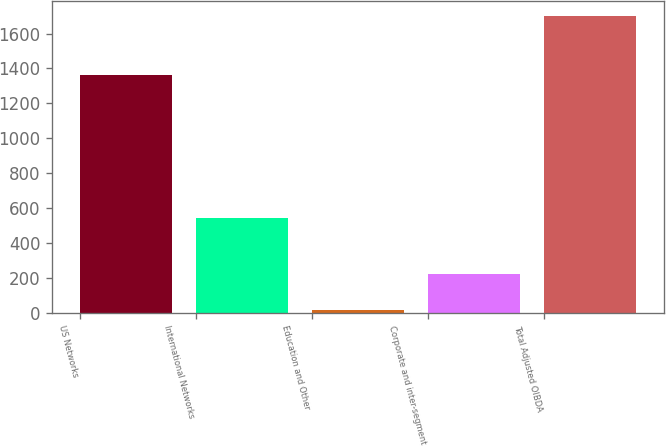Convert chart. <chart><loc_0><loc_0><loc_500><loc_500><bar_chart><fcel>US Networks<fcel>International Networks<fcel>Education and Other<fcel>Corporate and inter-segment<fcel>Total Adjusted OIBDA<nl><fcel>1365<fcel>545<fcel>15<fcel>226<fcel>1699<nl></chart> 